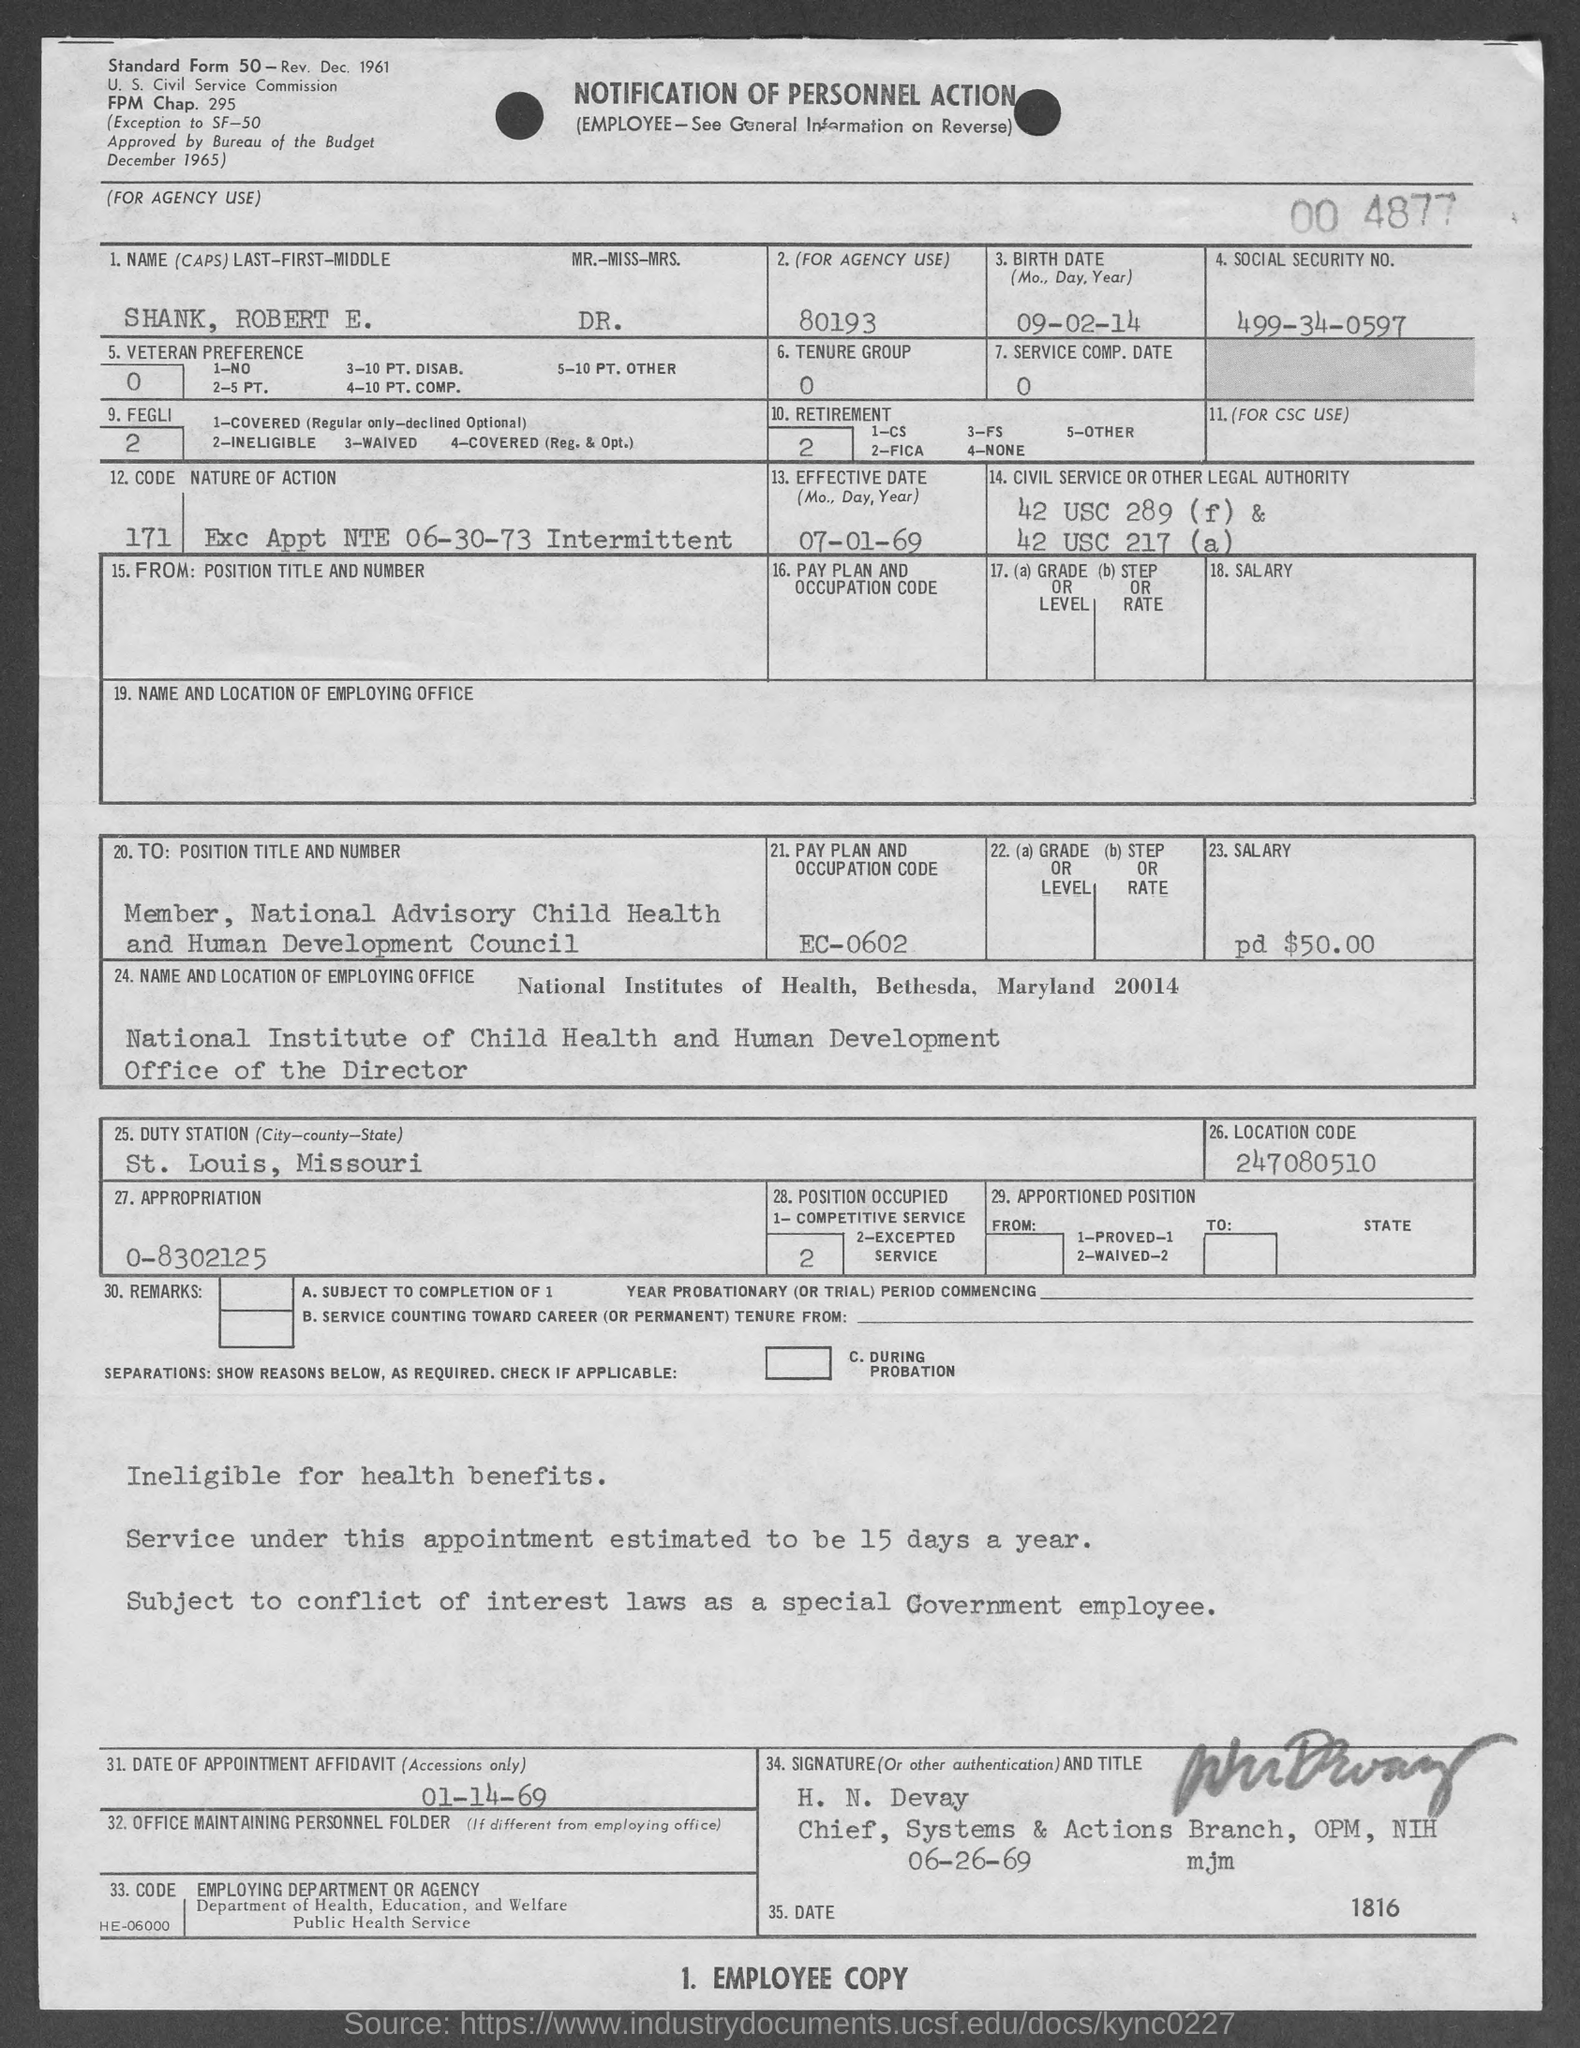Identify some key points in this picture. The social security number provided in the form is 499-34-0597. The birth date of Dr. Robert E. Shank is September 2, 2009. Mr. Robert E. Shank holds the position of Member of the National Advisory Child Health and Human Development Council. The pay plan and occupation code mentioned in the form is EC-0602. The affidavit provided in the form states that the date of the appointment is January 14th, 1969. 